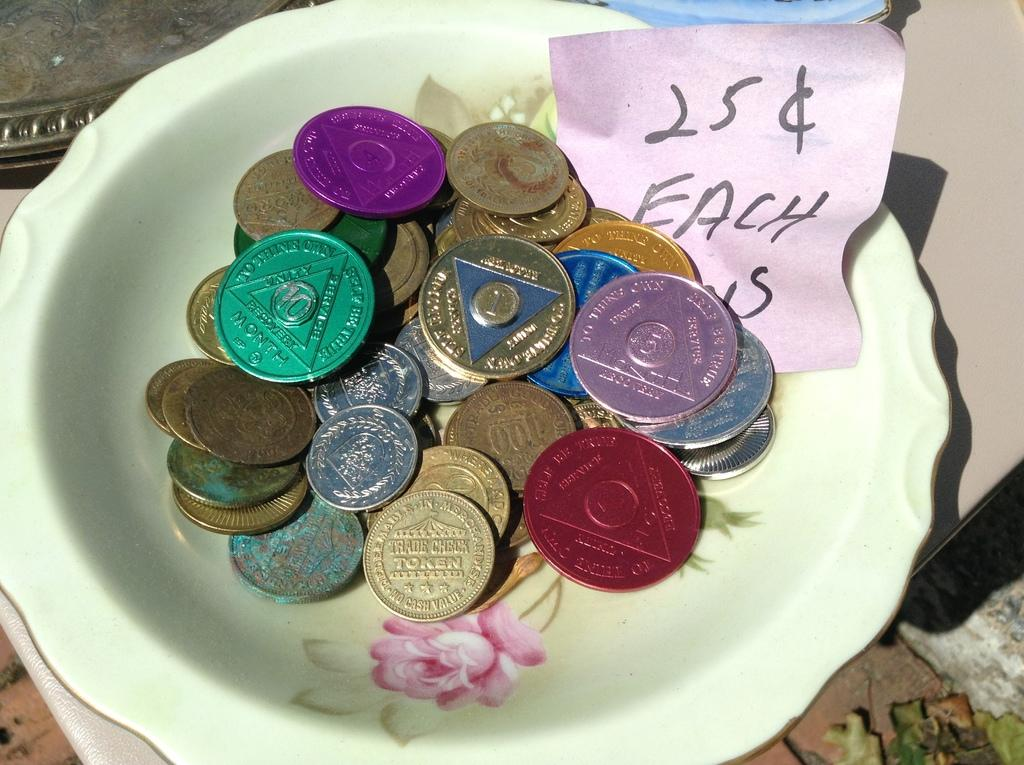<image>
Provide a brief description of the given image. A bowl of tokens are priced at 25 cents each. 